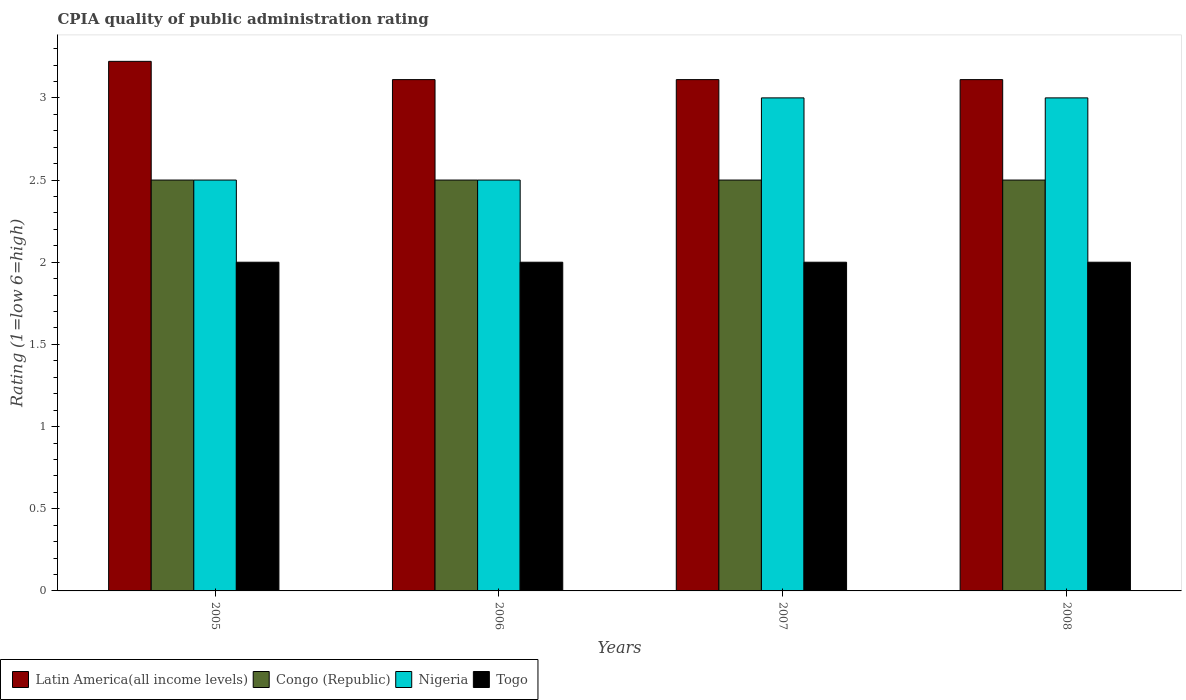How many different coloured bars are there?
Provide a succinct answer. 4. How many groups of bars are there?
Ensure brevity in your answer.  4. Are the number of bars per tick equal to the number of legend labels?
Your answer should be very brief. Yes. How many bars are there on the 2nd tick from the left?
Provide a succinct answer. 4. How many bars are there on the 3rd tick from the right?
Provide a succinct answer. 4. What is the label of the 1st group of bars from the left?
Offer a terse response. 2005. In how many cases, is the number of bars for a given year not equal to the number of legend labels?
Make the answer very short. 0. What is the CPIA rating in Congo (Republic) in 2007?
Your response must be concise. 2.5. Across all years, what is the maximum CPIA rating in Latin America(all income levels)?
Make the answer very short. 3.22. In which year was the CPIA rating in Latin America(all income levels) maximum?
Your answer should be very brief. 2005. What is the difference between the CPIA rating in Togo in 2007 and that in 2008?
Offer a very short reply. 0. What is the difference between the CPIA rating in Nigeria in 2007 and the CPIA rating in Latin America(all income levels) in 2008?
Keep it short and to the point. -0.11. In the year 2005, what is the difference between the CPIA rating in Latin America(all income levels) and CPIA rating in Togo?
Give a very brief answer. 1.22. Is the CPIA rating in Latin America(all income levels) in 2005 less than that in 2007?
Keep it short and to the point. No. What is the difference between the highest and the second highest CPIA rating in Latin America(all income levels)?
Make the answer very short. 0.11. What is the difference between the highest and the lowest CPIA rating in Latin America(all income levels)?
Offer a very short reply. 0.11. Is the sum of the CPIA rating in Latin America(all income levels) in 2005 and 2006 greater than the maximum CPIA rating in Togo across all years?
Ensure brevity in your answer.  Yes. What does the 4th bar from the left in 2006 represents?
Your answer should be very brief. Togo. What does the 3rd bar from the right in 2007 represents?
Keep it short and to the point. Congo (Republic). How many bars are there?
Provide a short and direct response. 16. What is the difference between two consecutive major ticks on the Y-axis?
Your answer should be compact. 0.5. Where does the legend appear in the graph?
Your answer should be very brief. Bottom left. How many legend labels are there?
Your response must be concise. 4. What is the title of the graph?
Give a very brief answer. CPIA quality of public administration rating. Does "Cameroon" appear as one of the legend labels in the graph?
Your answer should be very brief. No. What is the label or title of the X-axis?
Offer a terse response. Years. What is the label or title of the Y-axis?
Keep it short and to the point. Rating (1=low 6=high). What is the Rating (1=low 6=high) in Latin America(all income levels) in 2005?
Offer a very short reply. 3.22. What is the Rating (1=low 6=high) in Nigeria in 2005?
Ensure brevity in your answer.  2.5. What is the Rating (1=low 6=high) of Togo in 2005?
Your answer should be very brief. 2. What is the Rating (1=low 6=high) of Latin America(all income levels) in 2006?
Your response must be concise. 3.11. What is the Rating (1=low 6=high) in Nigeria in 2006?
Give a very brief answer. 2.5. What is the Rating (1=low 6=high) in Latin America(all income levels) in 2007?
Keep it short and to the point. 3.11. What is the Rating (1=low 6=high) of Congo (Republic) in 2007?
Your answer should be very brief. 2.5. What is the Rating (1=low 6=high) in Nigeria in 2007?
Make the answer very short. 3. What is the Rating (1=low 6=high) in Togo in 2007?
Give a very brief answer. 2. What is the Rating (1=low 6=high) in Latin America(all income levels) in 2008?
Keep it short and to the point. 3.11. What is the Rating (1=low 6=high) of Congo (Republic) in 2008?
Your answer should be compact. 2.5. What is the Rating (1=low 6=high) of Togo in 2008?
Offer a very short reply. 2. Across all years, what is the maximum Rating (1=low 6=high) in Latin America(all income levels)?
Make the answer very short. 3.22. Across all years, what is the maximum Rating (1=low 6=high) in Congo (Republic)?
Keep it short and to the point. 2.5. Across all years, what is the maximum Rating (1=low 6=high) in Nigeria?
Ensure brevity in your answer.  3. Across all years, what is the minimum Rating (1=low 6=high) of Latin America(all income levels)?
Make the answer very short. 3.11. Across all years, what is the minimum Rating (1=low 6=high) in Congo (Republic)?
Offer a terse response. 2.5. What is the total Rating (1=low 6=high) of Latin America(all income levels) in the graph?
Make the answer very short. 12.56. What is the total Rating (1=low 6=high) in Congo (Republic) in the graph?
Make the answer very short. 10. What is the total Rating (1=low 6=high) in Nigeria in the graph?
Your response must be concise. 11. What is the total Rating (1=low 6=high) of Togo in the graph?
Make the answer very short. 8. What is the difference between the Rating (1=low 6=high) in Togo in 2005 and that in 2006?
Make the answer very short. 0. What is the difference between the Rating (1=low 6=high) in Nigeria in 2005 and that in 2007?
Provide a succinct answer. -0.5. What is the difference between the Rating (1=low 6=high) of Nigeria in 2005 and that in 2008?
Provide a short and direct response. -0.5. What is the difference between the Rating (1=low 6=high) in Congo (Republic) in 2006 and that in 2007?
Your response must be concise. 0. What is the difference between the Rating (1=low 6=high) in Nigeria in 2006 and that in 2007?
Provide a short and direct response. -0.5. What is the difference between the Rating (1=low 6=high) of Latin America(all income levels) in 2006 and that in 2008?
Your answer should be very brief. 0. What is the difference between the Rating (1=low 6=high) in Congo (Republic) in 2006 and that in 2008?
Keep it short and to the point. 0. What is the difference between the Rating (1=low 6=high) in Togo in 2006 and that in 2008?
Make the answer very short. 0. What is the difference between the Rating (1=low 6=high) of Congo (Republic) in 2007 and that in 2008?
Keep it short and to the point. 0. What is the difference between the Rating (1=low 6=high) of Nigeria in 2007 and that in 2008?
Your response must be concise. 0. What is the difference between the Rating (1=low 6=high) in Latin America(all income levels) in 2005 and the Rating (1=low 6=high) in Congo (Republic) in 2006?
Offer a terse response. 0.72. What is the difference between the Rating (1=low 6=high) of Latin America(all income levels) in 2005 and the Rating (1=low 6=high) of Nigeria in 2006?
Provide a succinct answer. 0.72. What is the difference between the Rating (1=low 6=high) of Latin America(all income levels) in 2005 and the Rating (1=low 6=high) of Togo in 2006?
Offer a terse response. 1.22. What is the difference between the Rating (1=low 6=high) in Congo (Republic) in 2005 and the Rating (1=low 6=high) in Nigeria in 2006?
Your answer should be very brief. 0. What is the difference between the Rating (1=low 6=high) of Congo (Republic) in 2005 and the Rating (1=low 6=high) of Togo in 2006?
Keep it short and to the point. 0.5. What is the difference between the Rating (1=low 6=high) of Nigeria in 2005 and the Rating (1=low 6=high) of Togo in 2006?
Give a very brief answer. 0.5. What is the difference between the Rating (1=low 6=high) of Latin America(all income levels) in 2005 and the Rating (1=low 6=high) of Congo (Republic) in 2007?
Give a very brief answer. 0.72. What is the difference between the Rating (1=low 6=high) of Latin America(all income levels) in 2005 and the Rating (1=low 6=high) of Nigeria in 2007?
Your answer should be compact. 0.22. What is the difference between the Rating (1=low 6=high) of Latin America(all income levels) in 2005 and the Rating (1=low 6=high) of Togo in 2007?
Provide a succinct answer. 1.22. What is the difference between the Rating (1=low 6=high) in Congo (Republic) in 2005 and the Rating (1=low 6=high) in Togo in 2007?
Give a very brief answer. 0.5. What is the difference between the Rating (1=low 6=high) of Latin America(all income levels) in 2005 and the Rating (1=low 6=high) of Congo (Republic) in 2008?
Your answer should be very brief. 0.72. What is the difference between the Rating (1=low 6=high) of Latin America(all income levels) in 2005 and the Rating (1=low 6=high) of Nigeria in 2008?
Keep it short and to the point. 0.22. What is the difference between the Rating (1=low 6=high) of Latin America(all income levels) in 2005 and the Rating (1=low 6=high) of Togo in 2008?
Provide a short and direct response. 1.22. What is the difference between the Rating (1=low 6=high) of Latin America(all income levels) in 2006 and the Rating (1=low 6=high) of Congo (Republic) in 2007?
Provide a succinct answer. 0.61. What is the difference between the Rating (1=low 6=high) in Congo (Republic) in 2006 and the Rating (1=low 6=high) in Togo in 2007?
Offer a terse response. 0.5. What is the difference between the Rating (1=low 6=high) in Latin America(all income levels) in 2006 and the Rating (1=low 6=high) in Congo (Republic) in 2008?
Your answer should be compact. 0.61. What is the difference between the Rating (1=low 6=high) in Latin America(all income levels) in 2006 and the Rating (1=low 6=high) in Nigeria in 2008?
Your answer should be very brief. 0.11. What is the difference between the Rating (1=low 6=high) in Nigeria in 2006 and the Rating (1=low 6=high) in Togo in 2008?
Make the answer very short. 0.5. What is the difference between the Rating (1=low 6=high) of Latin America(all income levels) in 2007 and the Rating (1=low 6=high) of Congo (Republic) in 2008?
Make the answer very short. 0.61. What is the difference between the Rating (1=low 6=high) in Congo (Republic) in 2007 and the Rating (1=low 6=high) in Togo in 2008?
Give a very brief answer. 0.5. What is the average Rating (1=low 6=high) of Latin America(all income levels) per year?
Provide a succinct answer. 3.14. What is the average Rating (1=low 6=high) of Nigeria per year?
Make the answer very short. 2.75. In the year 2005, what is the difference between the Rating (1=low 6=high) of Latin America(all income levels) and Rating (1=low 6=high) of Congo (Republic)?
Your answer should be compact. 0.72. In the year 2005, what is the difference between the Rating (1=low 6=high) in Latin America(all income levels) and Rating (1=low 6=high) in Nigeria?
Ensure brevity in your answer.  0.72. In the year 2005, what is the difference between the Rating (1=low 6=high) of Latin America(all income levels) and Rating (1=low 6=high) of Togo?
Provide a succinct answer. 1.22. In the year 2006, what is the difference between the Rating (1=low 6=high) in Latin America(all income levels) and Rating (1=low 6=high) in Congo (Republic)?
Provide a succinct answer. 0.61. In the year 2006, what is the difference between the Rating (1=low 6=high) of Latin America(all income levels) and Rating (1=low 6=high) of Nigeria?
Keep it short and to the point. 0.61. In the year 2006, what is the difference between the Rating (1=low 6=high) in Latin America(all income levels) and Rating (1=low 6=high) in Togo?
Your answer should be very brief. 1.11. In the year 2006, what is the difference between the Rating (1=low 6=high) of Congo (Republic) and Rating (1=low 6=high) of Togo?
Provide a succinct answer. 0.5. In the year 2006, what is the difference between the Rating (1=low 6=high) of Nigeria and Rating (1=low 6=high) of Togo?
Make the answer very short. 0.5. In the year 2007, what is the difference between the Rating (1=low 6=high) in Latin America(all income levels) and Rating (1=low 6=high) in Congo (Republic)?
Provide a succinct answer. 0.61. In the year 2007, what is the difference between the Rating (1=low 6=high) of Latin America(all income levels) and Rating (1=low 6=high) of Nigeria?
Make the answer very short. 0.11. In the year 2007, what is the difference between the Rating (1=low 6=high) of Latin America(all income levels) and Rating (1=low 6=high) of Togo?
Provide a short and direct response. 1.11. In the year 2007, what is the difference between the Rating (1=low 6=high) in Congo (Republic) and Rating (1=low 6=high) in Nigeria?
Offer a very short reply. -0.5. In the year 2007, what is the difference between the Rating (1=low 6=high) in Congo (Republic) and Rating (1=low 6=high) in Togo?
Your answer should be very brief. 0.5. In the year 2008, what is the difference between the Rating (1=low 6=high) in Latin America(all income levels) and Rating (1=low 6=high) in Congo (Republic)?
Give a very brief answer. 0.61. In the year 2008, what is the difference between the Rating (1=low 6=high) of Latin America(all income levels) and Rating (1=low 6=high) of Nigeria?
Give a very brief answer. 0.11. In the year 2008, what is the difference between the Rating (1=low 6=high) in Latin America(all income levels) and Rating (1=low 6=high) in Togo?
Ensure brevity in your answer.  1.11. In the year 2008, what is the difference between the Rating (1=low 6=high) in Congo (Republic) and Rating (1=low 6=high) in Nigeria?
Your answer should be very brief. -0.5. What is the ratio of the Rating (1=low 6=high) in Latin America(all income levels) in 2005 to that in 2006?
Offer a terse response. 1.04. What is the ratio of the Rating (1=low 6=high) in Nigeria in 2005 to that in 2006?
Keep it short and to the point. 1. What is the ratio of the Rating (1=low 6=high) in Latin America(all income levels) in 2005 to that in 2007?
Make the answer very short. 1.04. What is the ratio of the Rating (1=low 6=high) in Latin America(all income levels) in 2005 to that in 2008?
Offer a very short reply. 1.04. What is the ratio of the Rating (1=low 6=high) in Congo (Republic) in 2005 to that in 2008?
Your answer should be compact. 1. What is the ratio of the Rating (1=low 6=high) in Latin America(all income levels) in 2006 to that in 2007?
Your answer should be very brief. 1. What is the ratio of the Rating (1=low 6=high) in Nigeria in 2006 to that in 2007?
Keep it short and to the point. 0.83. What is the ratio of the Rating (1=low 6=high) in Togo in 2006 to that in 2007?
Offer a very short reply. 1. What is the ratio of the Rating (1=low 6=high) in Congo (Republic) in 2006 to that in 2008?
Your answer should be compact. 1. What is the ratio of the Rating (1=low 6=high) in Nigeria in 2006 to that in 2008?
Keep it short and to the point. 0.83. What is the ratio of the Rating (1=low 6=high) in Togo in 2006 to that in 2008?
Make the answer very short. 1. What is the ratio of the Rating (1=low 6=high) in Togo in 2007 to that in 2008?
Offer a terse response. 1. What is the difference between the highest and the second highest Rating (1=low 6=high) of Congo (Republic)?
Provide a short and direct response. 0. What is the difference between the highest and the second highest Rating (1=low 6=high) in Nigeria?
Ensure brevity in your answer.  0. What is the difference between the highest and the second highest Rating (1=low 6=high) of Togo?
Your answer should be very brief. 0. What is the difference between the highest and the lowest Rating (1=low 6=high) of Nigeria?
Give a very brief answer. 0.5. 